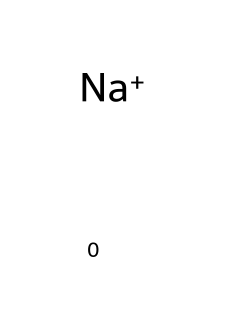What is the charge of this ion? The rendered chemical [Na+] shows the sodium ion, which is denoted by the [Na+] representation indicating it has a positive charge.
Answer: positive How many atoms are present in this chemical? The chemical representation [Na+] includes one sodium atom. Thus, there is a total of one atom present.
Answer: 1 What type of ion is represented by this structure? The structure [Na+] represents a cation because it carries a positive charge (indicated by the plus sign).
Answer: cation In what role does this ion primarily contribute to sports drinks? Sodium ions, as indicated in the structure, play a crucial role in regulating fluid balance and maintaining electrolyte levels in the body during physical activity.
Answer: electrolyte balance What might happen if there is a deficiency of this ion during exercise? A deficiency in sodium can lead to symptoms like muscle cramps, fatigue, and decreased performance due to poor electrolyte balance.
Answer: muscle cramps Why is this ion important for muscle function? Sodium ions are essential for generating action potentials in muscle cells, allowing for proper muscle contraction and nerve impulse transmission during exercise.
Answer: action potentials What is a common dietary source of this ion? Sodium is commonly found in table salt (sodium chloride), and its presence in food helps maintain the necessary electrolyte levels.
Answer: table salt 